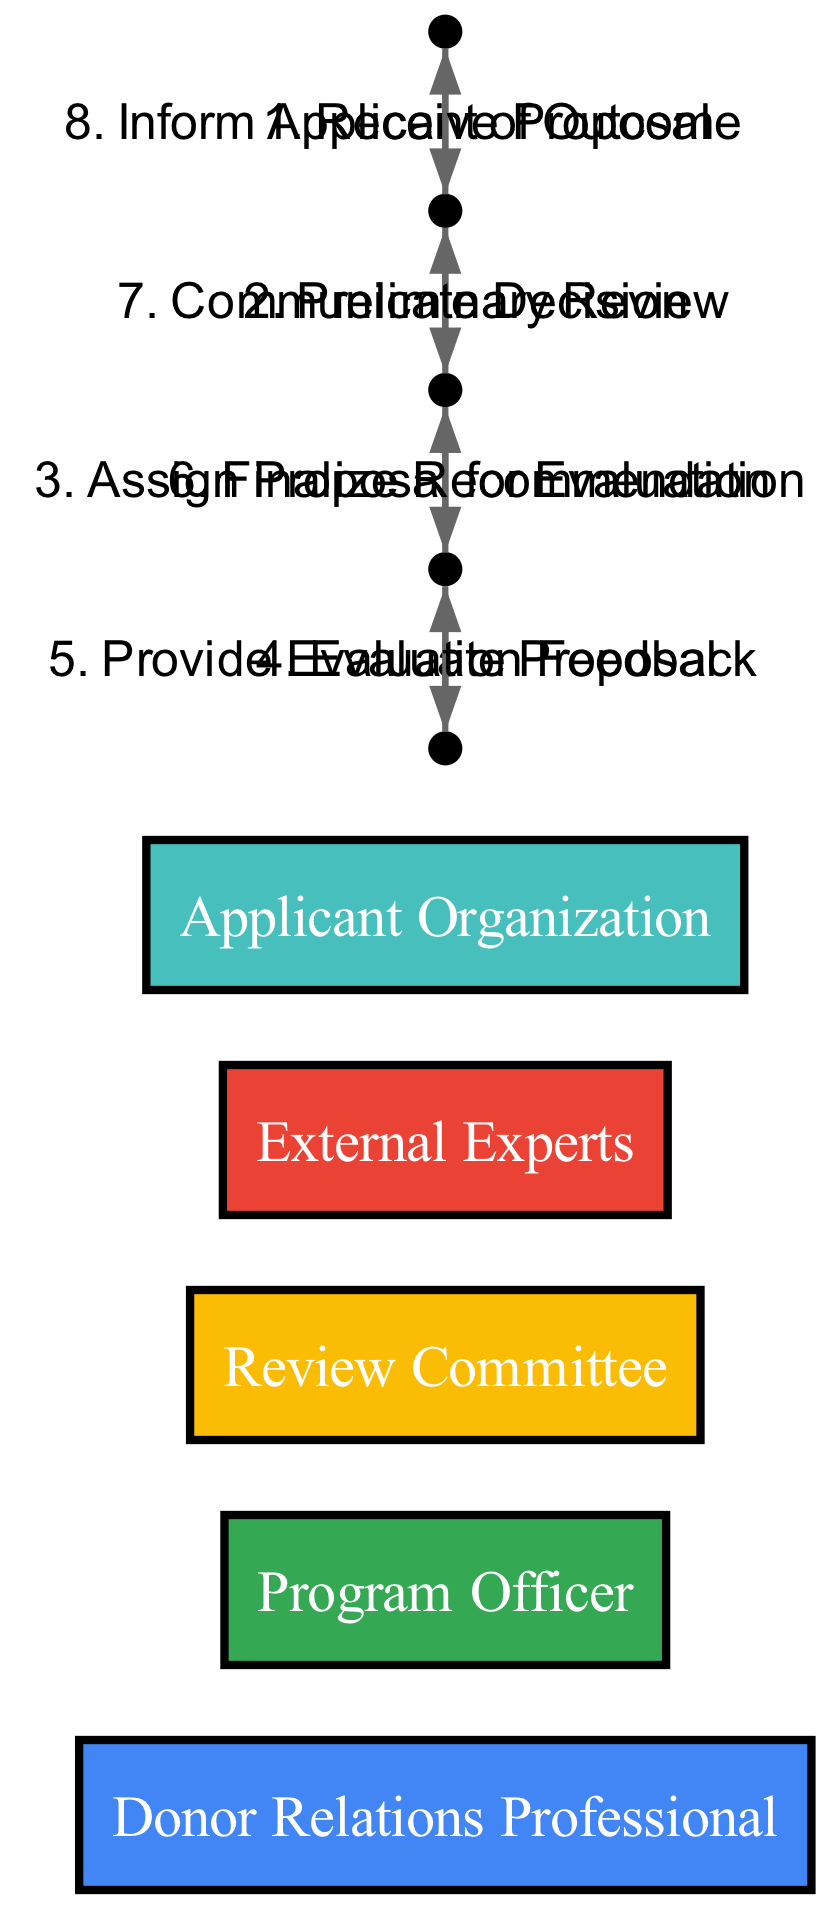What is the first action in the proposal evaluation process? The first action is identified by the step with ID 1 in the diagram, which states that the Applicant Organization receives a proposal.
Answer: Receive Proposal How many actors are involved in this process? The diagram lists five distinct actors involved in the proposal evaluation process.
Answer: Five Which actor is responsible for the 'Evaluate Proposal' step? The actor who initiates the 'Evaluate Proposal' action is the Review Committee; they evaluate the proposal received.
Answer: Review Committee What is the final action taken in the process? The last step in the sequence diagram is identified as step 8, which involves the Donor Relations Professional informing the Applicant Organization of the outcome.
Answer: Inform Applicant of Outcome Who receives the evaluation feedback from the External Experts? Based on step 5, the Review Committee receives evaluation feedback from External Experts, indicating the flow of feedback in the evaluation process.
Answer: Review Committee What action follows after the 'Assign Proposal for Evaluation' step? The action that follows is the 'Evaluate Proposal' step, as indicated by the flow of the process from the Program Officer to the Review Committee and then to the Evaluation phase.
Answer: Evaluate Proposal Which actor communicates the decision to the Donor Relations Professional? The Program Officer is responsible for communicating the decision as shown by step 7 in the diagram, connecting the Program Officer and Donor Relations Professional.
Answer: Program Officer In the sequence, how many steps are directly between the 'Receive Proposal' and the 'Inform Applicant of Outcome'? To find this, count the steps between step 1 ('Receive Proposal') and step 8 ('Inform Applicant of Outcome'), which totals six steps in between.
Answer: Six steps What is the function of the 'Review Committee' in the process? The Review Committee plays a key role in evaluating the proposal and providing feedback based on the evaluation, which is reflected through multiple steps involving them.
Answer: Evaluate Proposal and Provide Evaluation Feedback 